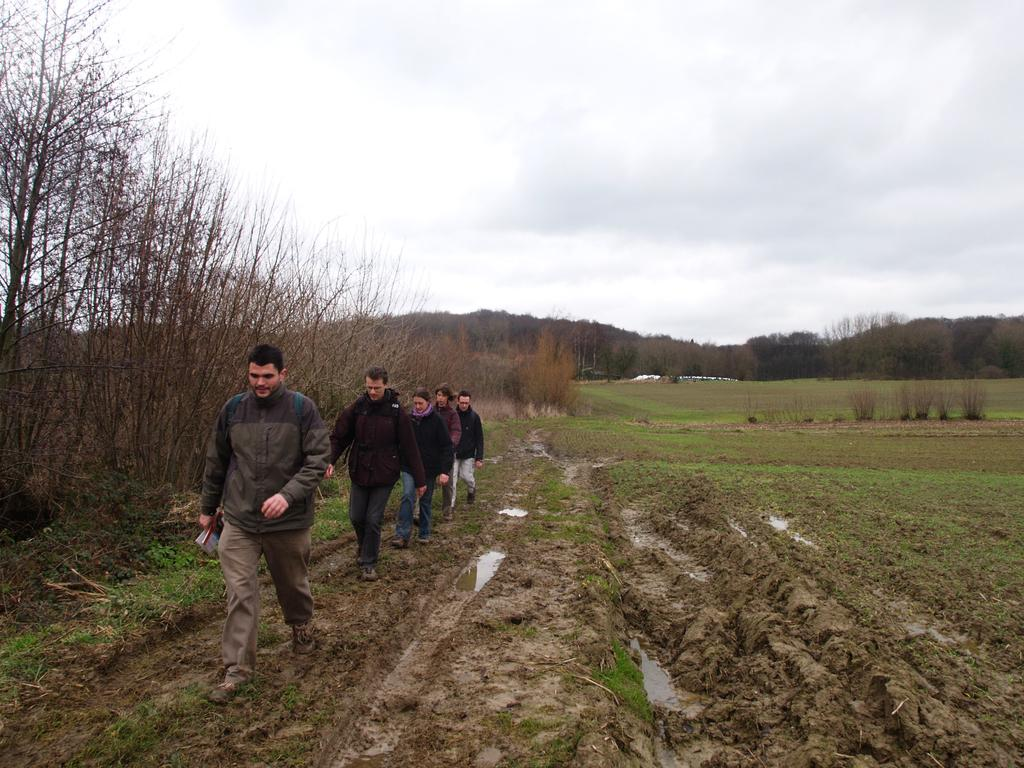What are the persons in the image doing? The persons in the image are walking. What type of terrain is visible in the image? The soil is visible in the image. What type of vegetation is present in the image? There is grass in the image. What natural element is visible in the image? There is water visible in the image. What type of plant life is present in the image? There are trees in the image. What is visible in the background of the image? The sky is visible in the image. What type of rhythm can be heard in the image? There is no audible rhythm present in the image, as it is a still photograph. 